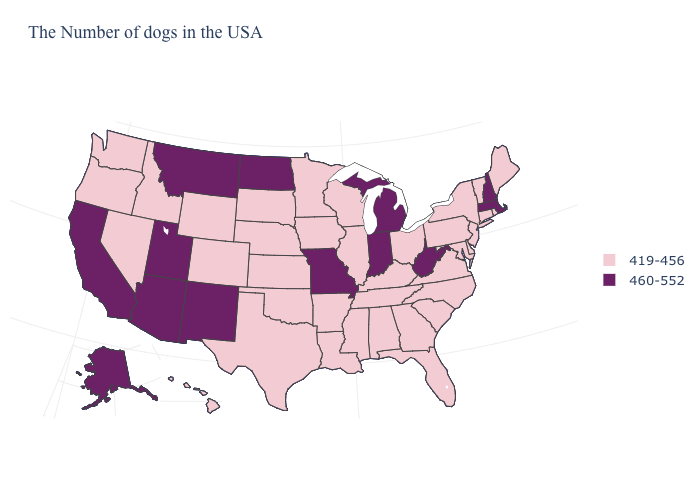Does Nevada have the lowest value in the USA?
Concise answer only. Yes. Is the legend a continuous bar?
Keep it brief. No. What is the lowest value in the USA?
Concise answer only. 419-456. Name the states that have a value in the range 460-552?
Give a very brief answer. Massachusetts, New Hampshire, West Virginia, Michigan, Indiana, Missouri, North Dakota, New Mexico, Utah, Montana, Arizona, California, Alaska. What is the lowest value in states that border Maryland?
Quick response, please. 419-456. Name the states that have a value in the range 460-552?
Give a very brief answer. Massachusetts, New Hampshire, West Virginia, Michigan, Indiana, Missouri, North Dakota, New Mexico, Utah, Montana, Arizona, California, Alaska. Among the states that border Nevada , does Idaho have the lowest value?
Be succinct. Yes. What is the lowest value in the USA?
Keep it brief. 419-456. Does Alaska have the highest value in the USA?
Be succinct. Yes. Does Washington have a lower value than Maine?
Write a very short answer. No. Does Maryland have a lower value than Washington?
Concise answer only. No. Name the states that have a value in the range 419-456?
Be succinct. Maine, Rhode Island, Vermont, Connecticut, New York, New Jersey, Delaware, Maryland, Pennsylvania, Virginia, North Carolina, South Carolina, Ohio, Florida, Georgia, Kentucky, Alabama, Tennessee, Wisconsin, Illinois, Mississippi, Louisiana, Arkansas, Minnesota, Iowa, Kansas, Nebraska, Oklahoma, Texas, South Dakota, Wyoming, Colorado, Idaho, Nevada, Washington, Oregon, Hawaii. Name the states that have a value in the range 419-456?
Short answer required. Maine, Rhode Island, Vermont, Connecticut, New York, New Jersey, Delaware, Maryland, Pennsylvania, Virginia, North Carolina, South Carolina, Ohio, Florida, Georgia, Kentucky, Alabama, Tennessee, Wisconsin, Illinois, Mississippi, Louisiana, Arkansas, Minnesota, Iowa, Kansas, Nebraska, Oklahoma, Texas, South Dakota, Wyoming, Colorado, Idaho, Nevada, Washington, Oregon, Hawaii. What is the lowest value in the MidWest?
Write a very short answer. 419-456. Does Michigan have the highest value in the USA?
Short answer required. Yes. 